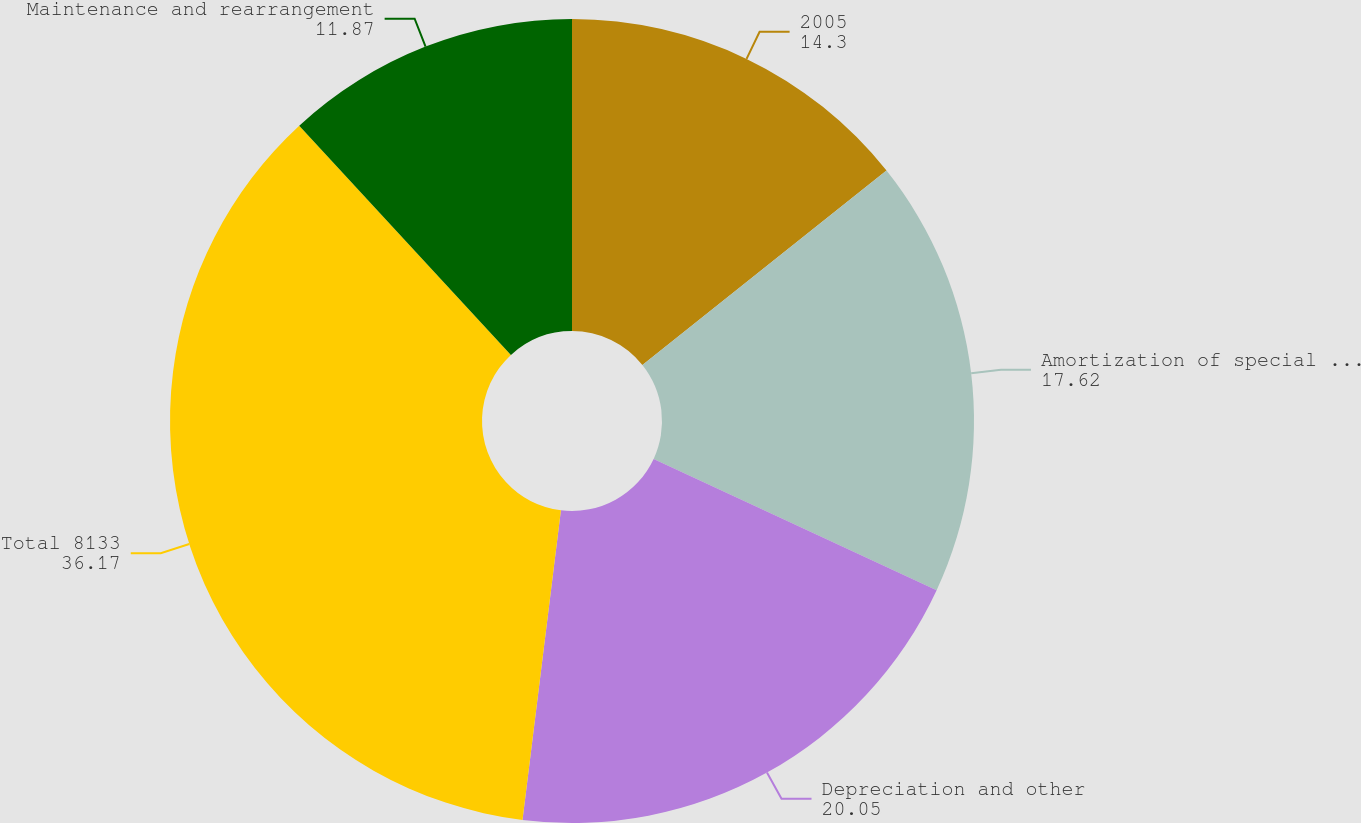Convert chart. <chart><loc_0><loc_0><loc_500><loc_500><pie_chart><fcel>2005<fcel>Amortization of special tools<fcel>Depreciation and other<fcel>Total 8133<fcel>Maintenance and rearrangement<nl><fcel>14.3%<fcel>17.62%<fcel>20.05%<fcel>36.17%<fcel>11.87%<nl></chart> 